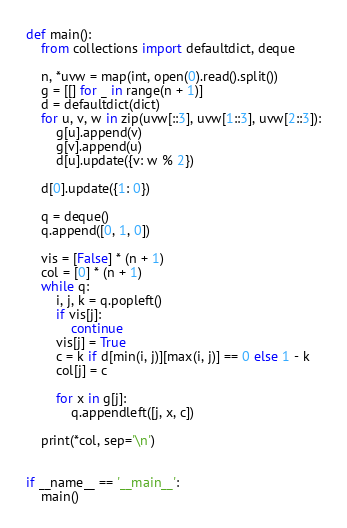Convert code to text. <code><loc_0><loc_0><loc_500><loc_500><_Python_>def main():
    from collections import defaultdict, deque

    n, *uvw = map(int, open(0).read().split())
    g = [[] for _ in range(n + 1)]
    d = defaultdict(dict)
    for u, v, w in zip(uvw[::3], uvw[1::3], uvw[2::3]):
        g[u].append(v)
        g[v].append(u)
        d[u].update({v: w % 2})

    d[0].update({1: 0})

    q = deque()
    q.append([0, 1, 0])

    vis = [False] * (n + 1)
    col = [0] * (n + 1)
    while q:
        i, j, k = q.popleft()
        if vis[j]:
            continue
        vis[j] = True
        c = k if d[min(i, j)][max(i, j)] == 0 else 1 - k
        col[j] = c

        for x in g[j]:
            q.appendleft([j, x, c])

    print(*col, sep='\n')


if __name__ == '__main__':
    main()
</code> 